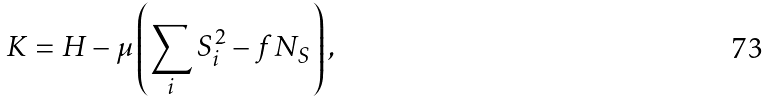<formula> <loc_0><loc_0><loc_500><loc_500>K = H - \mu \left ( \sum _ { i } S _ { i } ^ { 2 } - f N _ { S } \right ) ,</formula> 